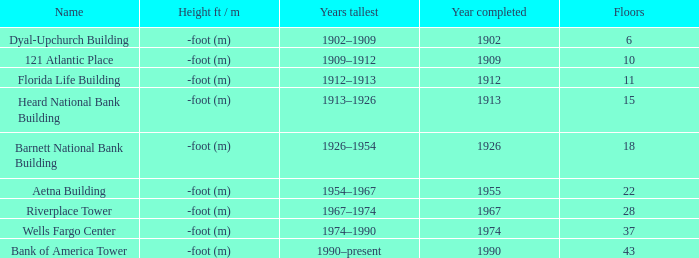How tall is the florida life building, completed before 1990? -foot (m). 